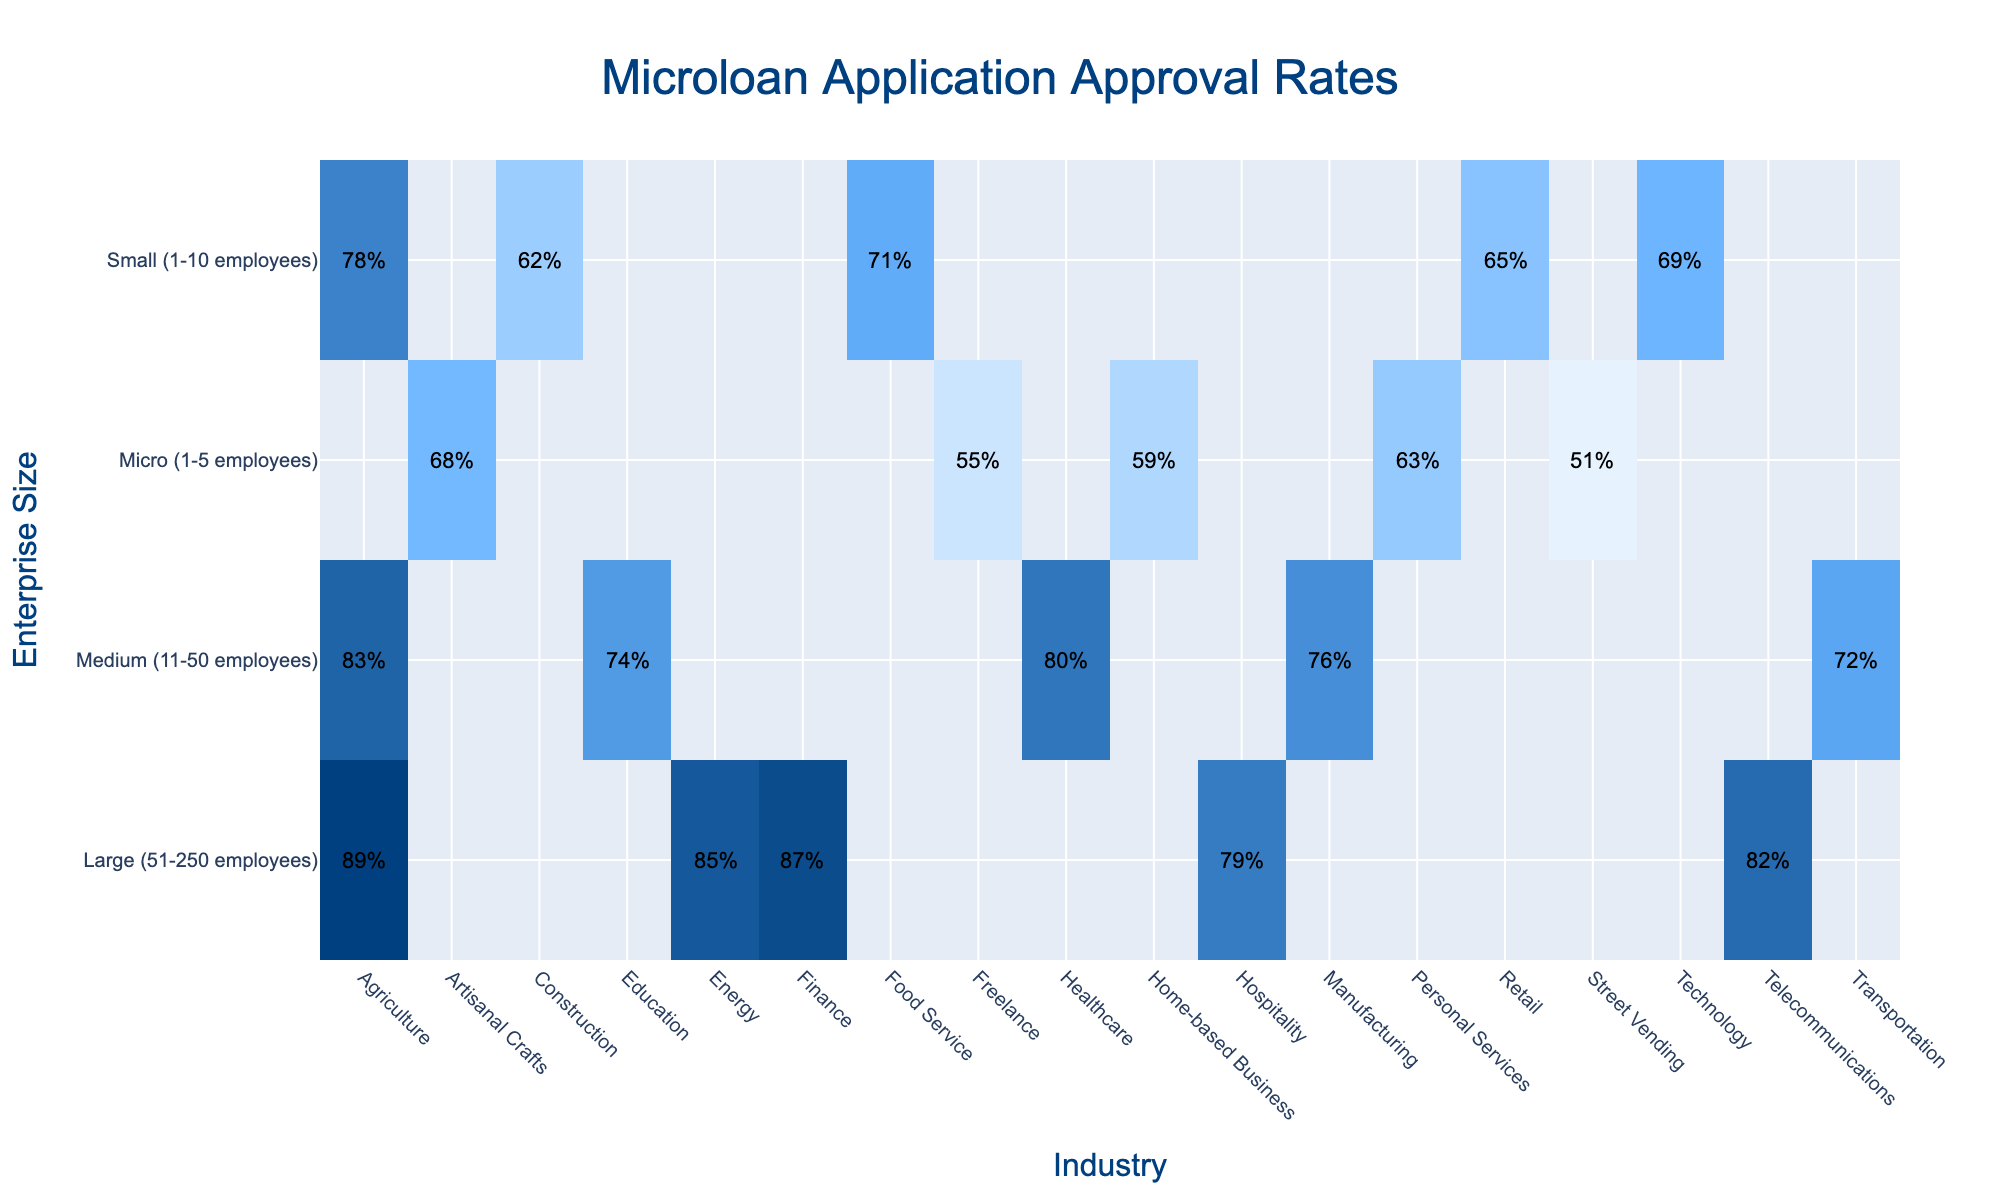What is the approval rate for small enterprises in the retail industry? The approval rate for small enterprises (1-10 employees) in the retail industry can be found directly in the table, which indicates it is 65%.
Answer: 65% Which industry has the highest approval rate for medium-sized enterprises? By reviewing the approval rates listed for medium-sized enterprises (11-50 employees), agriculture has the highest approval rate at 83%.
Answer: 83% Is the approval rate for large enterprises in agriculture higher than in hospitality? The approval rate for large enterprises in agriculture is 89%, while in hospitality, it is 79%. Since 89% is greater than 79%, the statement is true.
Answer: Yes What is the difference in approval rates between large enterprises in finance and medium enterprises in manufacturing? The approval rate for large enterprises in finance is 87%, and for medium enterprises in manufacturing, it is 76%. The difference is calculated as 87% - 76% = 11%.
Answer: 11% Which size of enterprise has the lowest overall approval rate across all industries? By looking across all the data, the micro enterprises (1-5 employees) consistently show lower approval rates, with the highest being 68% in artisanal crafts and the lowest being 51% in street vending. Thus, micro enterprises have the lowest overall approval rate.
Answer: Micro What is the average approval rate for small enterprises across all industries? The approval rates for small enterprises are 78%, 65%, 71%, 62%, and 69%. Adding these together gives 345%, and dividing by the number of industries (5) gives an average of 69%.
Answer: 69% Are the approval rates for micro enterprises in personal services higher than for micro enterprises in street vending? The approval rate for micro enterprises in personal services is 63% and for street vending is 51%. Since 63% is greater than 51%, the statement is true.
Answer: Yes Which enterprise size has the most consistent approval rates across industries? By examining the table, medium-sized enterprises show relatively higher approval rates across all their listed industries (ranging from 72% to 83%), indicating a more consistent approval rate pattern compared to others.
Answer: Medium What is the collective approval rate of small enterprises in food service and construction? The approval rate for small enterprises in food service is 71% and in construction is 62%. Sum these rates: 71% + 62% = 133%.
Answer: 133% What industry has the lowest approval rate for micro enterprises? For micro enterprises, the approval rate for street vending is the lowest at 51%, according to the table.
Answer: 51% What is the overall best industry for approval rates regardless of enterprise size? By examining the highest approval rates across all enterprise sizes, agriculture has the highest rate of 89% for large enterprises, making it the overall best industry for approval rates.
Answer: Agriculture 